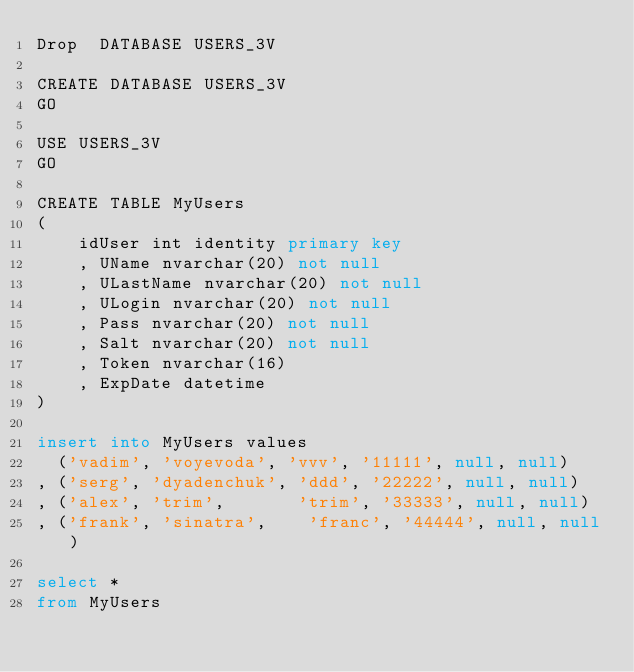Convert code to text. <code><loc_0><loc_0><loc_500><loc_500><_SQL_>Drop  DATABASE USERS_3V

CREATE DATABASE USERS_3V
GO

USE USERS_3V
GO

CREATE TABLE MyUsers
(
	idUser int identity primary key
	, UName nvarchar(20) not null
	, ULastName nvarchar(20) not null
	, ULogin nvarchar(20) not null
	, Pass nvarchar(20) not null
	, Salt nvarchar(20) not null
	, Token nvarchar(16)
	, ExpDate datetime
)

insert into MyUsers values
  ('vadim', 'voyevoda', 'vvv', '11111', null, null)
, ('serg', 'dyadenchuk', 'ddd', '22222', null, null)
, ('alex', 'trim',       'trim', '33333', null, null)
, ('frank', 'sinatra',    'franc', '44444', null, null)

select *
from MyUsers</code> 